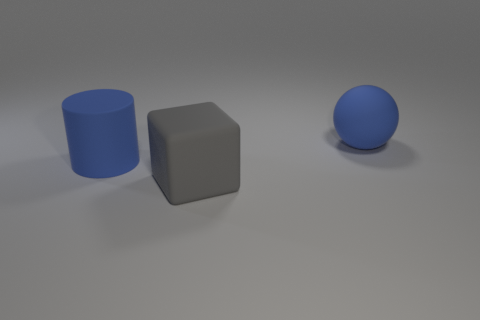There is a cylinder that is the same material as the block; what color is it?
Make the answer very short. Blue. How many blue rubber objects are the same size as the gray matte thing?
Your answer should be compact. 2. How many other objects are the same color as the cylinder?
Your answer should be very brief. 1. There is a rubber object that is to the left of the big gray matte cube; does it have the same shape as the large thing that is in front of the cylinder?
Make the answer very short. No. There is a blue matte object that is the same size as the cylinder; what shape is it?
Offer a very short reply. Sphere. Is the number of big matte objects that are right of the blue matte sphere the same as the number of gray rubber cubes behind the matte block?
Your answer should be very brief. Yes. Is there anything else that has the same shape as the gray object?
Make the answer very short. No. Is the large object on the left side of the gray block made of the same material as the large gray thing?
Keep it short and to the point. Yes. There is a blue object that is the same size as the rubber ball; what is its material?
Keep it short and to the point. Rubber. What number of other things are made of the same material as the cylinder?
Your answer should be very brief. 2. 